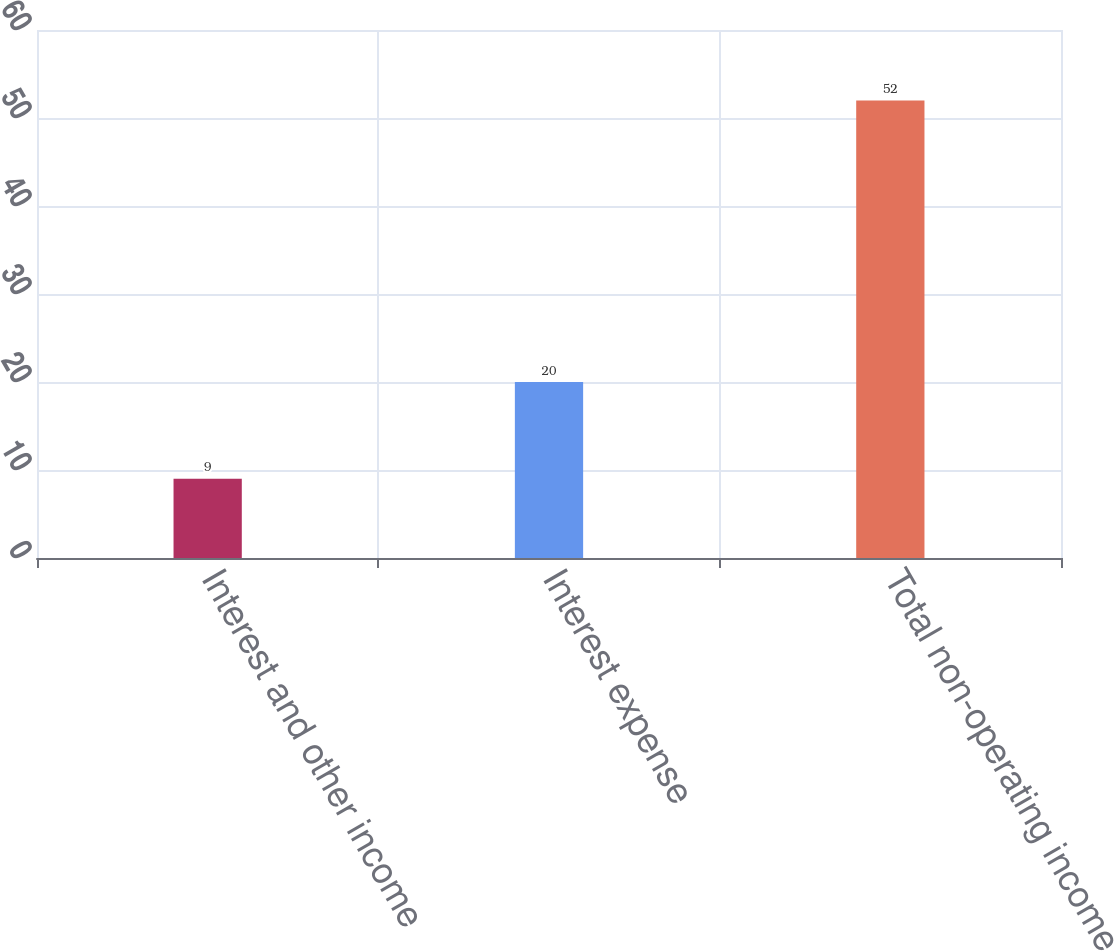<chart> <loc_0><loc_0><loc_500><loc_500><bar_chart><fcel>Interest and other income<fcel>Interest expense<fcel>Total non-operating income<nl><fcel>9<fcel>20<fcel>52<nl></chart> 